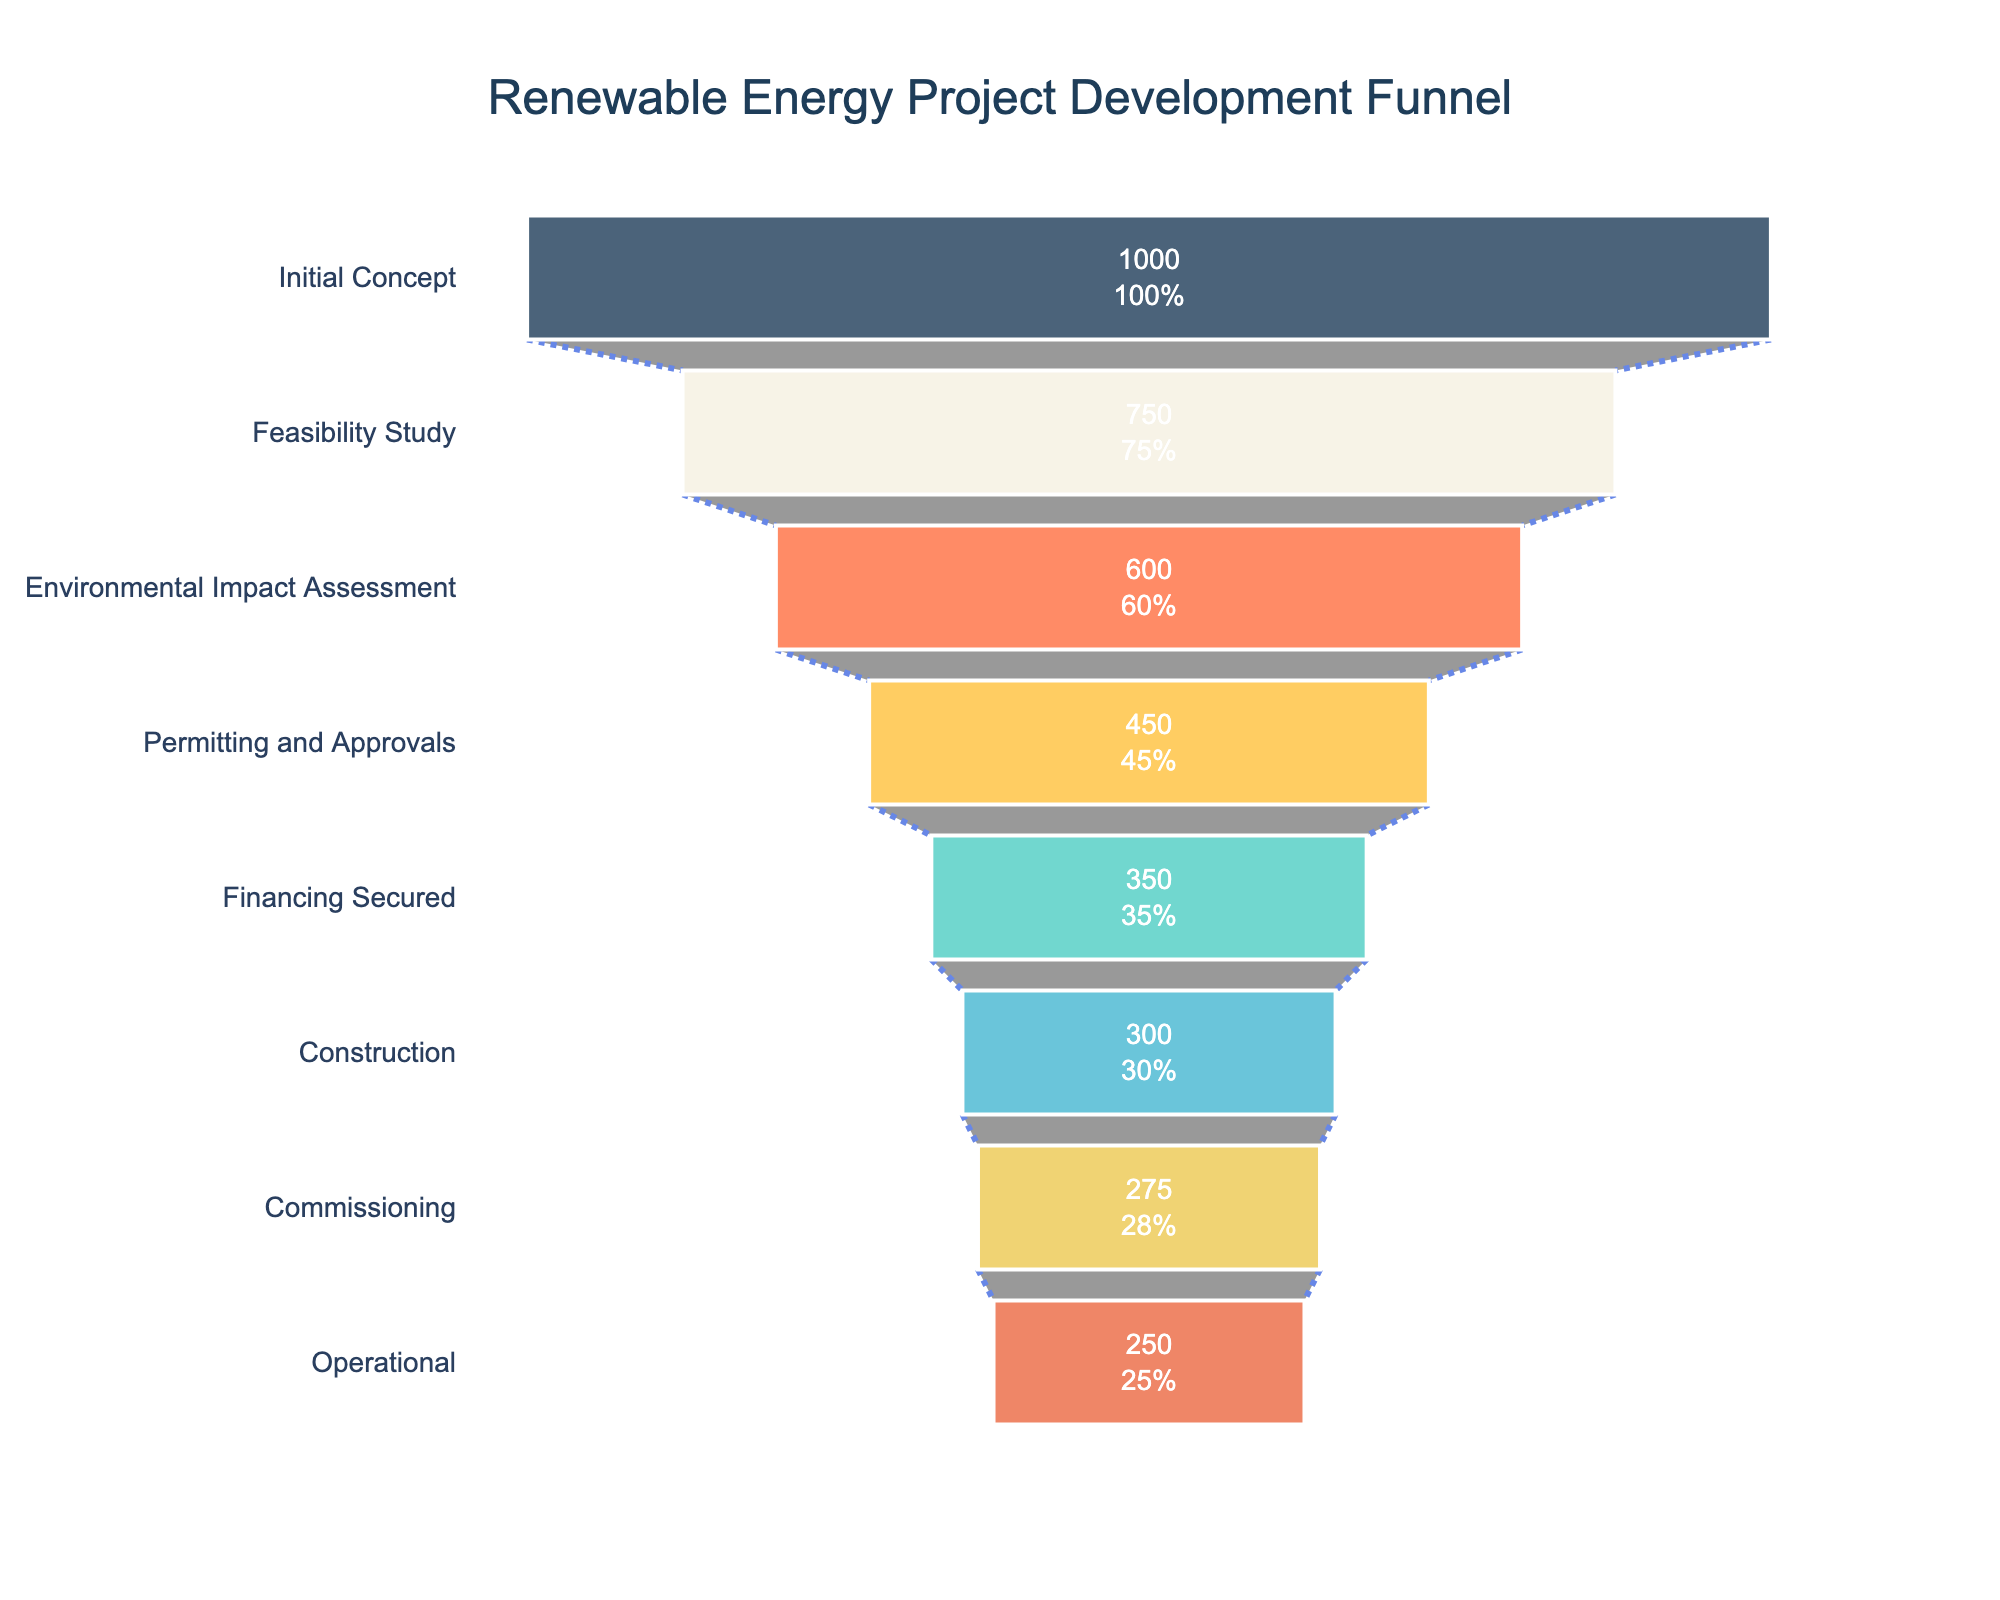What's the title of the chart? The title is prominently displayed at the top of the chart. It summarizes the overall focus of the visual representation.
Answer: Renewable Energy Project Development Funnel How many stages are there in the project development? You can count the number of distinct stages listed on the y-axis of the funnel.
Answer: 8 Which stage has the highest number of projects? The stage with the highest number of projects will have the longest bar within the funnel chart, typically the first stage.
Answer: Initial Concept What is the success rate at the Permitting and Approvals stage? Look for the success rate mentioned next to the Permitting and Approvals stage in the chart.
Answer: 45% How many projects reach the Operational stage? Find the number of projects for the Operational stage as mentioned in the chart.
Answer: 250 What is the difference in the number of projects between the Initial Concept and Financing Secured stages? Subtract the number of projects at the Financing Secured stage from those at the Initial Concept stage (1000 - 350).
Answer: 650 Which stage has a higher number of projects: Feasibility Study or Environmental Impact Assessment? Compare the length of the bars (or the numbers) for these two stages.
Answer: Feasibility Study What percentage of the Initial Concept projects reach the Commissioning stage? Multiply the initial number of projects by the success rates through each stage up to the Commissioning stage (1000 * 0.75 * 0.60 * 0.45 * 0.35 * 0.30 * 0.275). However, the chart directly shows the number, and the percentage can also be read from the chart at the specific stage.
Answer: 27.5% What is the drop in the number of projects from the Construction to the Operational stage? Subtract the number of projects at the Operational stage from those at the Construction stage (300 - 250).
Answer: 50 Which stage shows the most significant drop in project numbers? Identify the stage where the difference between successive stages is the largest by looking at the length reduction in the bars.
Answer: Permitting and Approvals 